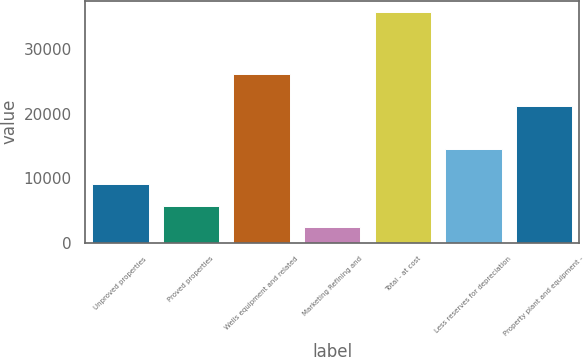<chart> <loc_0><loc_0><loc_500><loc_500><bar_chart><fcel>Unproved properties<fcel>Proved properties<fcel>Wells equipment and related<fcel>Marketing Refining and<fcel>Total - at cost<fcel>Less reserves for depreciation<fcel>Property plant and equipment -<nl><fcel>9018.2<fcel>5682.6<fcel>26064<fcel>2347<fcel>35703<fcel>14576<fcel>21127<nl></chart> 